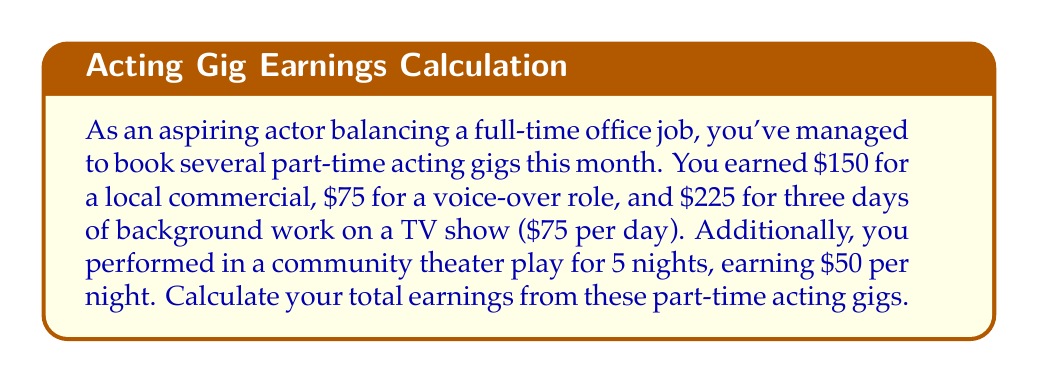Provide a solution to this math problem. To find the total earnings, we need to add up all the individual payments from the various acting gigs. Let's break it down step by step:

1. Local commercial earnings: $150
2. Voice-over role earnings: $75
3. Background work earnings: $225 (given as $75 per day for 3 days)
4. Community theater play earnings: 
   We need to multiply the per-night payment by the number of nights performed.
   $$ 50 \text{ dollars/night} \times 5 \text{ nights} = $250 $$

Now, let's add up all these earnings:

$$ \text{Total Earnings} = 150 + 75 + 225 + 250 $$

$$ \text{Total Earnings} = $700 $$
Answer: $700 